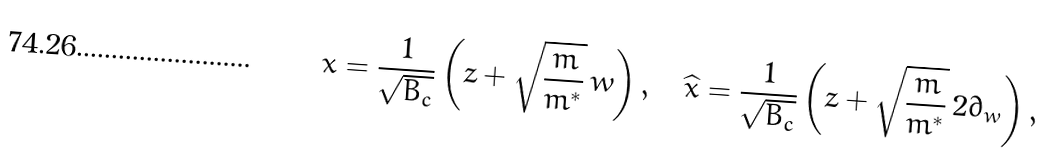<formula> <loc_0><loc_0><loc_500><loc_500>x = \frac { 1 } { \sqrt { B _ { c } } } \left ( z + \sqrt { \frac { m } { m ^ { * } } } \, \bar { w } \right ) , \quad \widehat { x } = \frac { 1 } { \sqrt { B _ { c } } } \left ( z + \sqrt { \frac { m } { m ^ { * } } } \, 2 \partial _ { w } \right ) ,</formula> 